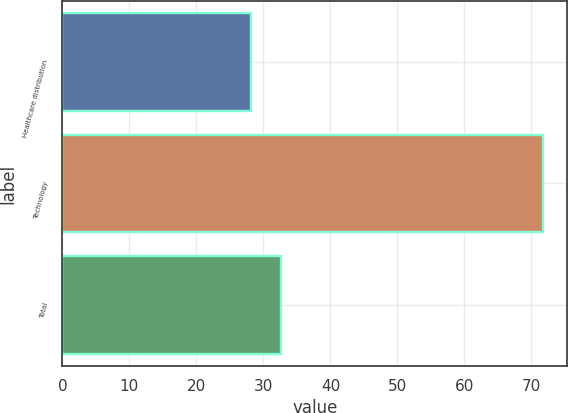Convert chart. <chart><loc_0><loc_0><loc_500><loc_500><bar_chart><fcel>Healthcare distribution<fcel>Technology<fcel>Total<nl><fcel>28.2<fcel>71.8<fcel>32.56<nl></chart> 